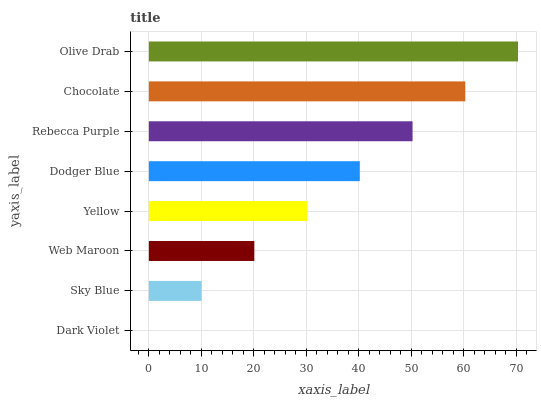Is Dark Violet the minimum?
Answer yes or no. Yes. Is Olive Drab the maximum?
Answer yes or no. Yes. Is Sky Blue the minimum?
Answer yes or no. No. Is Sky Blue the maximum?
Answer yes or no. No. Is Sky Blue greater than Dark Violet?
Answer yes or no. Yes. Is Dark Violet less than Sky Blue?
Answer yes or no. Yes. Is Dark Violet greater than Sky Blue?
Answer yes or no. No. Is Sky Blue less than Dark Violet?
Answer yes or no. No. Is Dodger Blue the high median?
Answer yes or no. Yes. Is Yellow the low median?
Answer yes or no. Yes. Is Sky Blue the high median?
Answer yes or no. No. Is Rebecca Purple the low median?
Answer yes or no. No. 